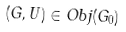<formula> <loc_0><loc_0><loc_500><loc_500>( G , U ) \in O b j ( G _ { 0 } )</formula> 